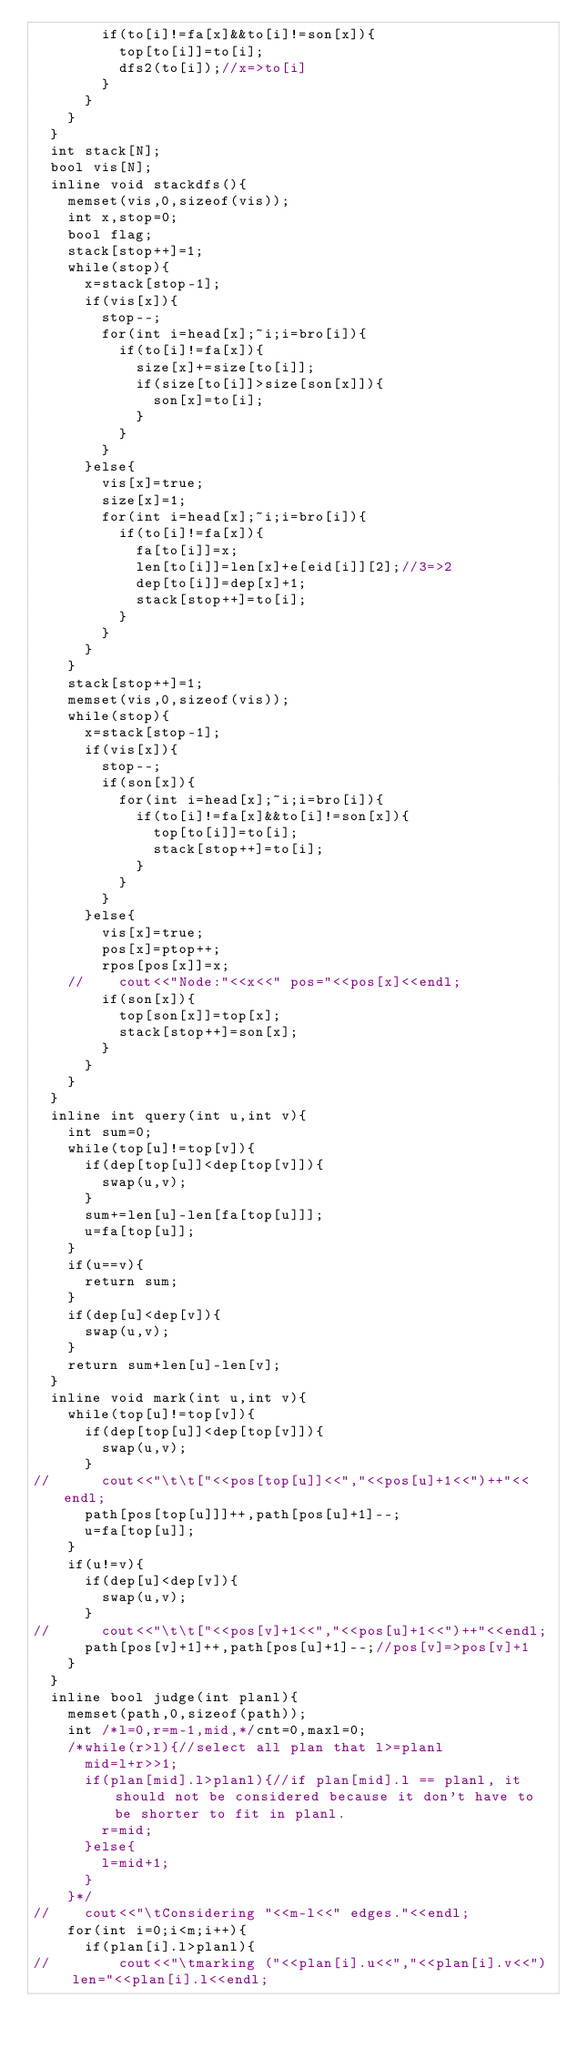Convert code to text. <code><loc_0><loc_0><loc_500><loc_500><_C++_>				if(to[i]!=fa[x]&&to[i]!=son[x]){
					top[to[i]]=to[i];
					dfs2(to[i]);//x=>to[i]
				}
			}
		}
	}
	int stack[N];
	bool vis[N];
	inline void stackdfs(){
		memset(vis,0,sizeof(vis));
		int x,stop=0;
		bool flag;
		stack[stop++]=1;
		while(stop){
			x=stack[stop-1];
			if(vis[x]){
				stop--;
				for(int i=head[x];~i;i=bro[i]){
					if(to[i]!=fa[x]){
						size[x]+=size[to[i]];
						if(size[to[i]]>size[son[x]]){
							son[x]=to[i];
						}
					}
				}
			}else{
				vis[x]=true;
				size[x]=1;
				for(int i=head[x];~i;i=bro[i]){
					if(to[i]!=fa[x]){
						fa[to[i]]=x;
						len[to[i]]=len[x]+e[eid[i]][2];//3=>2
						dep[to[i]]=dep[x]+1;
						stack[stop++]=to[i];
					}
				}
			}
		}
		stack[stop++]=1;
		memset(vis,0,sizeof(vis));
		while(stop){
			x=stack[stop-1];
			if(vis[x]){
				stop--;
				if(son[x]){
					for(int i=head[x];~i;i=bro[i]){
						if(to[i]!=fa[x]&&to[i]!=son[x]){
							top[to[i]]=to[i];
							stack[stop++]=to[i];
						}
					}
				}
			}else{
				vis[x]=true;
				pos[x]=ptop++;
				rpos[pos[x]]=x;
		//		cout<<"Node:"<<x<<" pos="<<pos[x]<<endl;
				if(son[x]){
					top[son[x]]=top[x];
					stack[stop++]=son[x];
				}
			}
		}
	}
	inline int query(int u,int v){
		int sum=0;
		while(top[u]!=top[v]){
			if(dep[top[u]]<dep[top[v]]){
				swap(u,v);
			}
			sum+=len[u]-len[fa[top[u]]];
			u=fa[top[u]];
		}
		if(u==v){
			return sum;
		}
		if(dep[u]<dep[v]){
			swap(u,v);
		}
		return sum+len[u]-len[v];
	}
	inline void mark(int u,int v){
		while(top[u]!=top[v]){
			if(dep[top[u]]<dep[top[v]]){
				swap(u,v);
			}
//			cout<<"\t\t["<<pos[top[u]]<<","<<pos[u]+1<<")++"<<endl;
			path[pos[top[u]]]++,path[pos[u]+1]--;
			u=fa[top[u]];
		}
		if(u!=v){
			if(dep[u]<dep[v]){
				swap(u,v);
			}
//			cout<<"\t\t["<<pos[v]+1<<","<<pos[u]+1<<")++"<<endl;
			path[pos[v]+1]++,path[pos[u]+1]--;//pos[v]=>pos[v]+1
		}
	}
	inline bool judge(int planl){
		memset(path,0,sizeof(path));
		int /*l=0,r=m-1,mid,*/cnt=0,maxl=0;
		/*while(r>l){//select all plan that l>=planl
			mid=l+r>>1;
			if(plan[mid].l>planl){//if plan[mid].l == planl, it should not be considered because it don't have to be shorter to fit in planl.
				r=mid;
			}else{
				l=mid+1;
			}
		}*/
//		cout<<"\tConsidering "<<m-l<<" edges."<<endl;
		for(int i=0;i<m;i++){
			if(plan[i].l>planl){
//				cout<<"\tmarking ("<<plan[i].u<<","<<plan[i].v<<") len="<<plan[i].l<<endl;</code> 